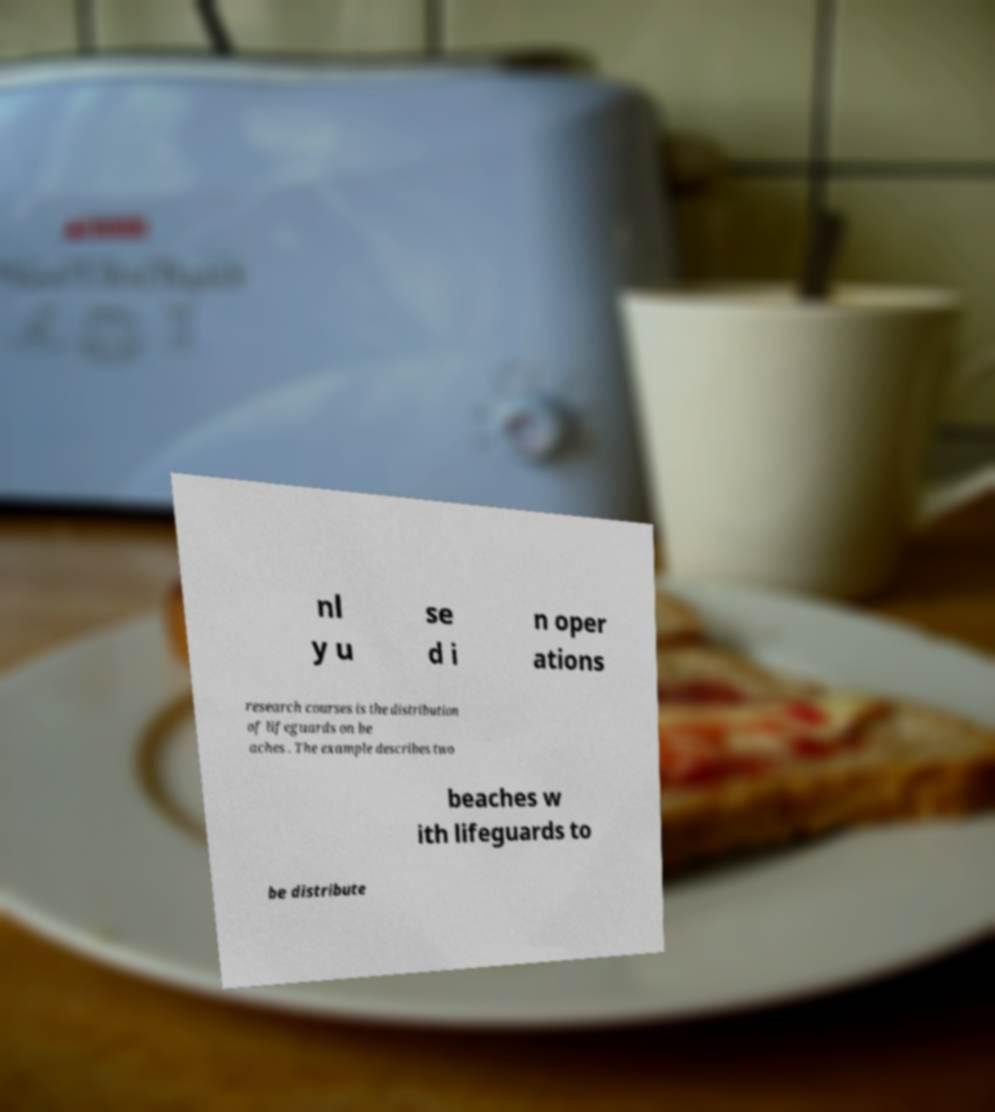What messages or text are displayed in this image? I need them in a readable, typed format. nl y u se d i n oper ations research courses is the distribution of lifeguards on be aches . The example describes two beaches w ith lifeguards to be distribute 